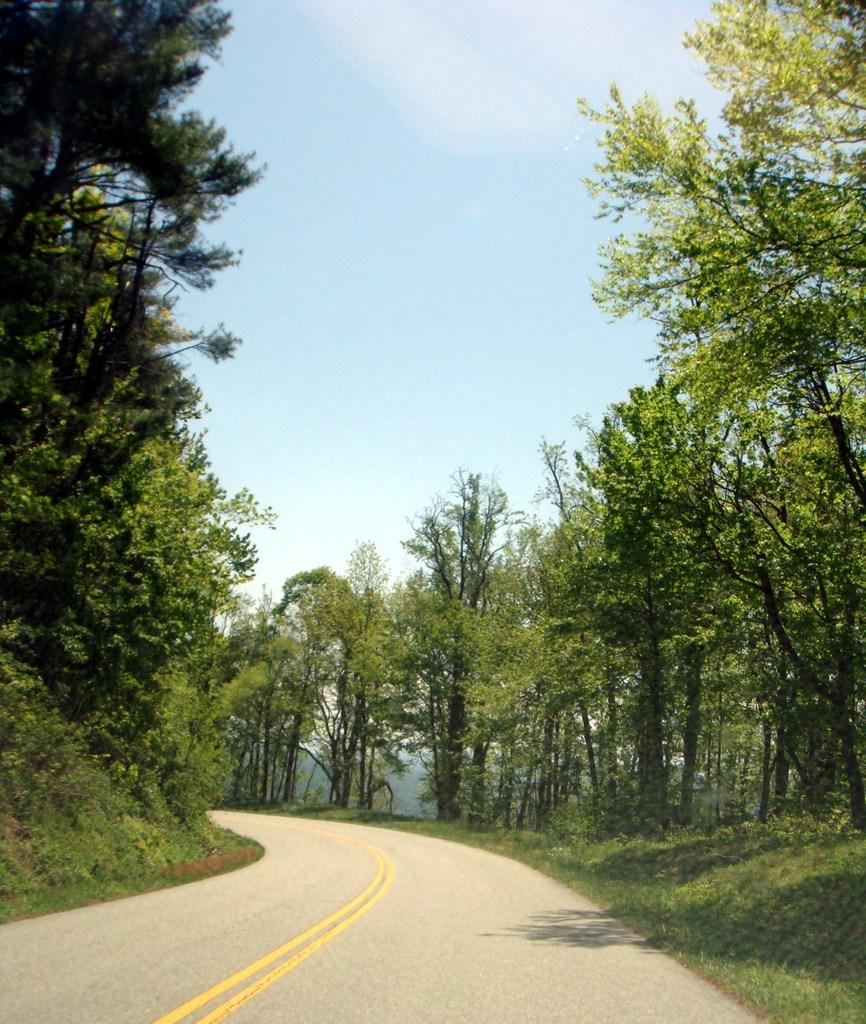What can be seen at the bottom of the image? There is a road and grass at the bottom of the image. What is located in the middle of the image? There are trees in the middle of the image. What is visible in the sky at the top of the image? There are clouds visible in the sky at the top of the image. Can you tell me how many goats are standing on the scale in the image? There are no goats or scales present in the image. What type of balls can be seen in the image? There are no balls present in the image. 